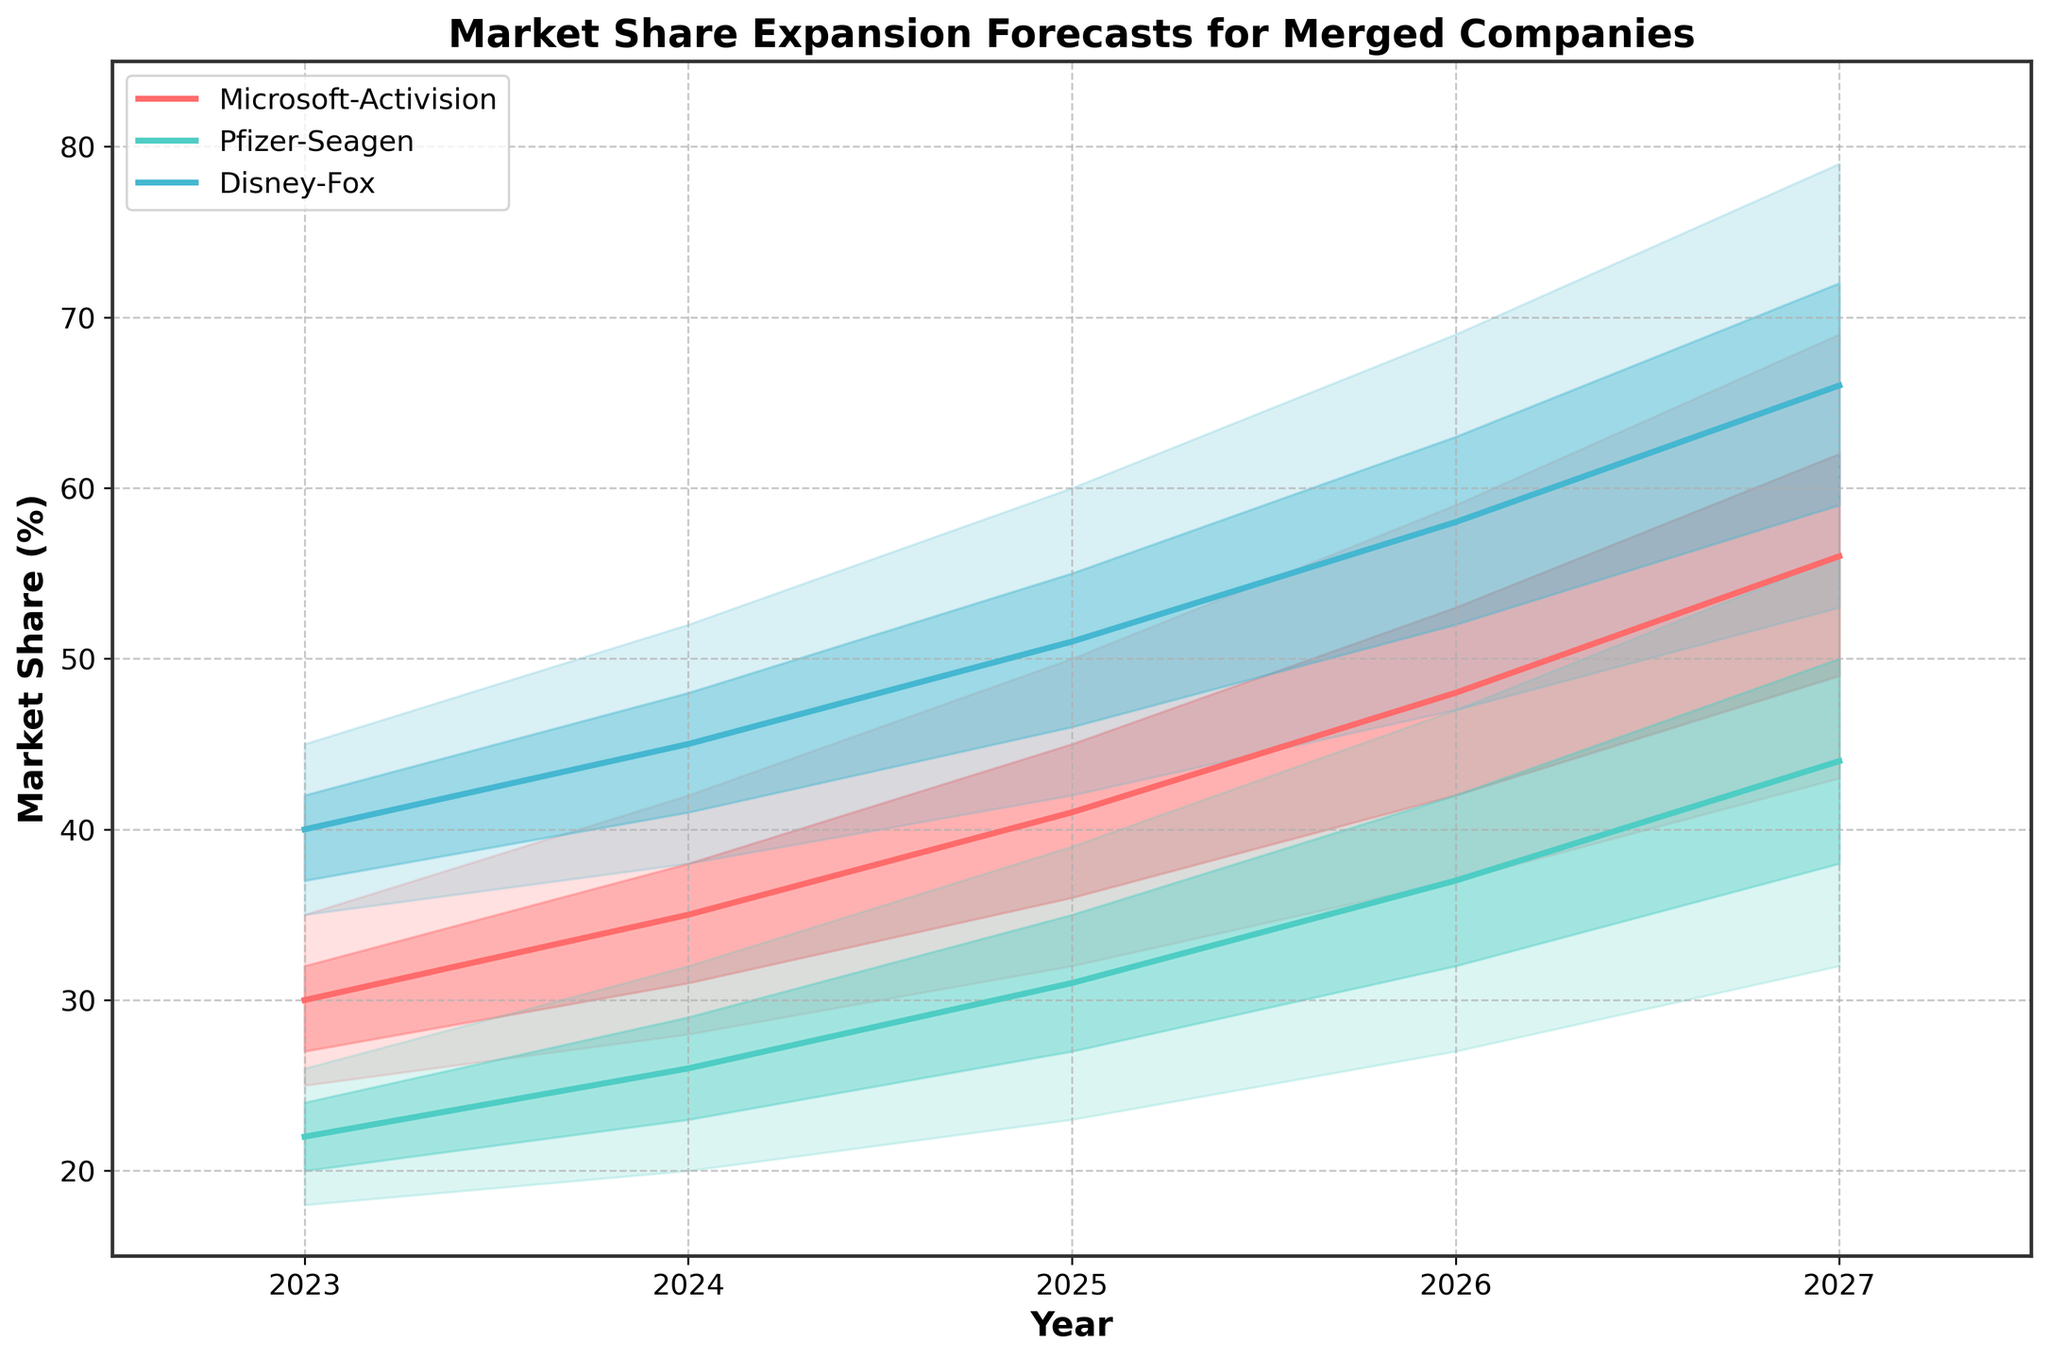What's the title of the plot? The title is located at the top of the plot. It reads, "Market Share Expansion Forecasts for Merged Companies".
Answer: Market Share Expansion Forecasts for Merged Companies How does the market share forecast for Disney-Fox change from 2023 to 2024 in the middle range? The middle range forecast for Disney-Fox in 2023 is 40%, and in 2024 it is 45%. The difference between these years is 45% - 40% = 5%.
Answer: Increases by 5% Which company has the highest high-end forecast for market share in 2027? For 2027, the high-end forecast across companies needs to be checked. Microsoft-Activision is at 69%, Pfizer-Seagen is at 56%, and Disney-Fox is at 79%. Disney-Fox's high-end forecast is the highest.
Answer: Disney-Fox What range does the forecast for Pfizer-Seagen span in 2026? For 2026, the low-end and high-end forecasts for Pfizer-Seagen are 27% and 47%, respectively. The range is calculated as 47% - 27% = 20%.
Answer: 20% How does the mid-range forecast for Microsoft-Activision compare between 2023 and 2025? The mid-range forecast for Microsoft-Activision in 2023 is 30%, and in 2025 it increases to 41%. The difference is 41% - 30% = 11%.
Answer: Increases by 11% Which company's market share forecast shows the most significant increase in the middle value from 2024 to 2025? The forecasts need to be compared: Microsoft-Activision from 35% to 41% (6%), Pfizer-Seagen from 26% to 31% (5%), Disney-Fox from 45% to 51% (6%). Both Microsoft-Activision and Disney-Fox show an increase of 6%.
Answer: Microsoft-Activision and Disney-Fox What is the expected market share for Pfizer-Seagen in the mid-high range in 2027? The mid-high range forecast for the Pfizer-Seagen in 2027 is indicated directly in the plot. For Pfizer-Seagen, it is 50%.
Answer: 50% By how much does the market share for Disney-Fox grow in the high-end forecast between 2025 and 2026? The high-end forecast for Disney-Fox in 2025 is 60%, and in 2026 it is 69%. The difference is calculated as 69% - 60% = 9%.
Answer: 9% What's the average mid-range market share forecast for all companies in 2024? The mid-range market share in 2024: Microsoft-Activision (35%), Pfizer-Seagen (26%), and Disney-Fox (45%). The sum is 35 + 26 + 45 = 106. The average is 106 / 3 = 35.3%.
Answer: 35.3% Which company's market share is expected to show the most dynamic fluctuation within the forecast range in 2027? The fluctuation within the forecast range is measured by the difference between the high and low estimates. For 2027: Microsoft-Activision (69% - 43% = 26%), Pfizer-Seagen (56% - 32% = 24%), Disney-Fox (79% - 53% = 26%). Both Microsoft-Activision and Disney-Fox show the most fluctuation.
Answer: Microsoft-Activision and Disney-Fox 